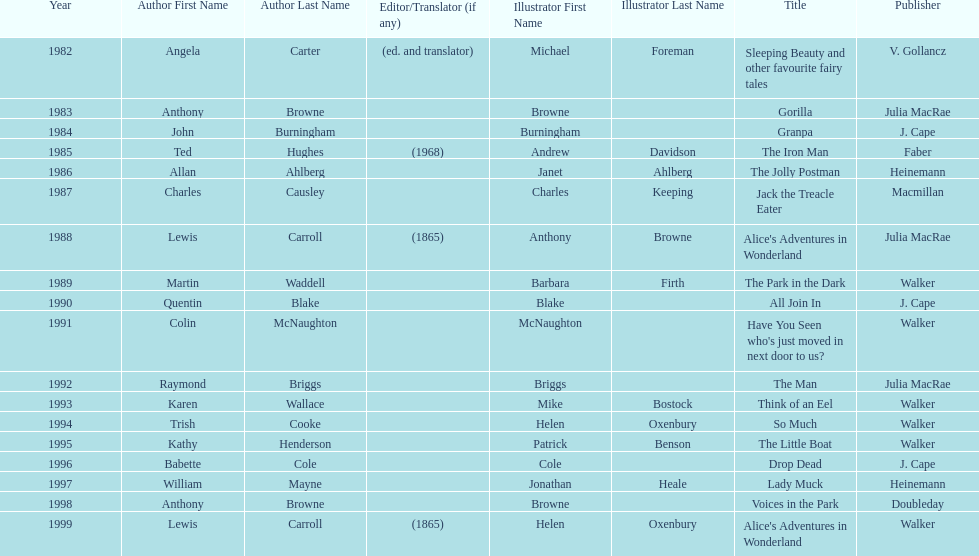Which author wrote the first award winner? Angela Carter. 